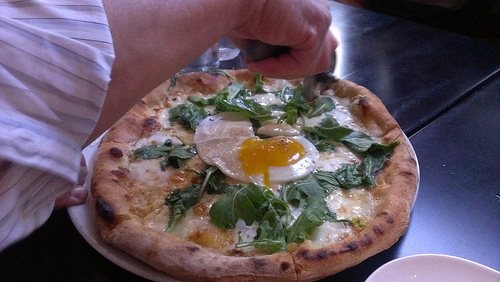What is the egg on? The egg is on top of spinach. 